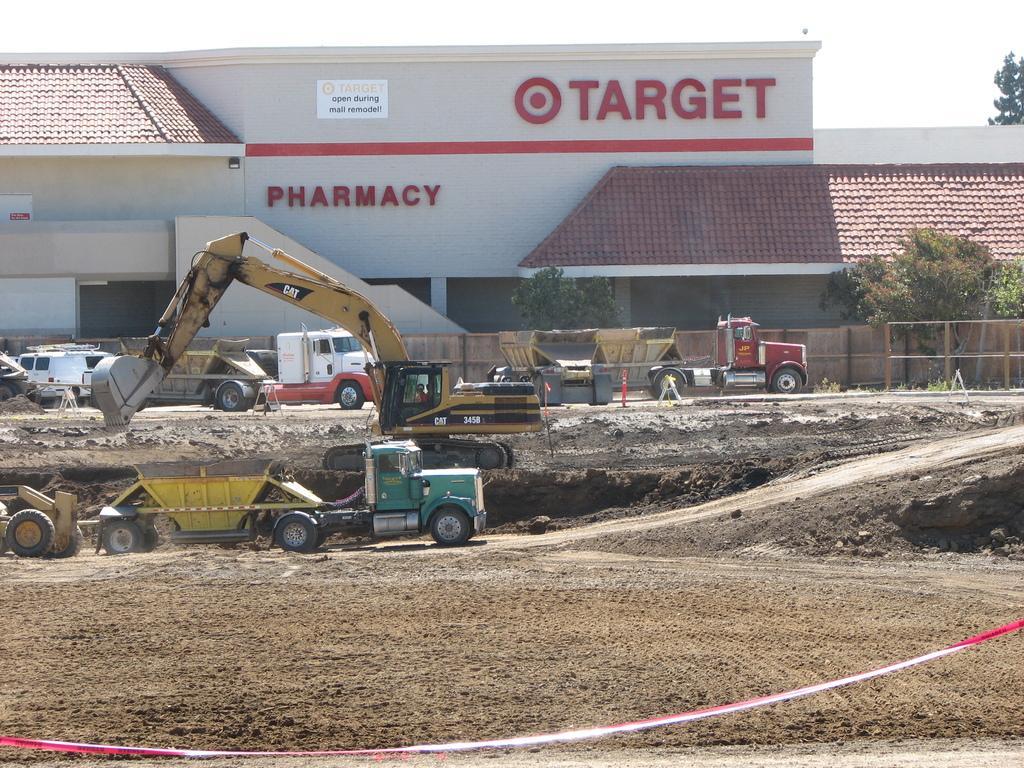Could you give a brief overview of what you see in this image? In this image, we can see vehicles on the ground and in the background, there are traffic cones, a ribbon and we can see a building, trees and there is a fence. 